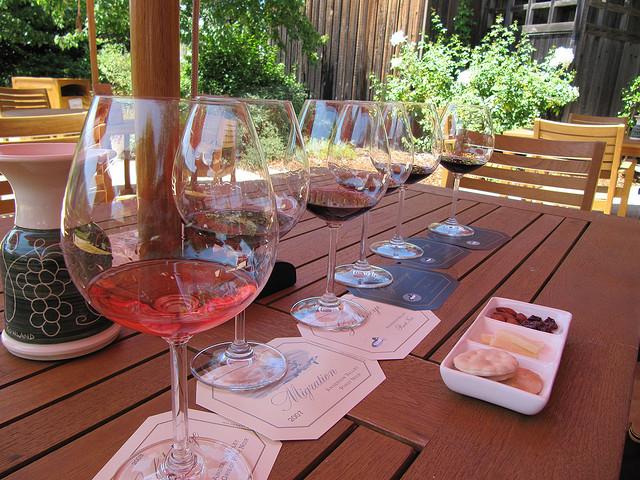Which glass likely contains a rose wine?
Write a very short answer. Closest one. What is placed on the table in a white plate?
Short answer required. Food. Is this a wine tasting?
Concise answer only. Yes. 